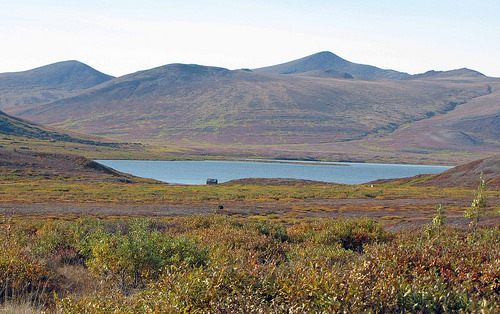<image>
Can you confirm if the water is under the hills? Yes. The water is positioned underneath the hills, with the hills above it in the vertical space. 